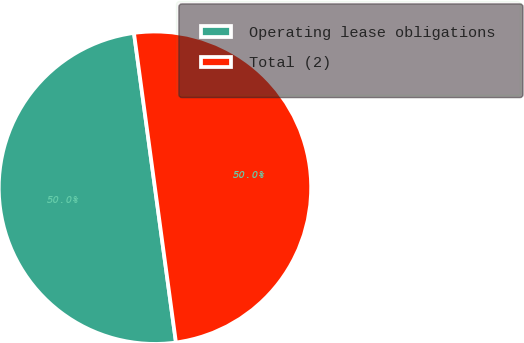<chart> <loc_0><loc_0><loc_500><loc_500><pie_chart><fcel>Operating lease obligations<fcel>Total (2)<nl><fcel>50.0%<fcel>50.0%<nl></chart> 